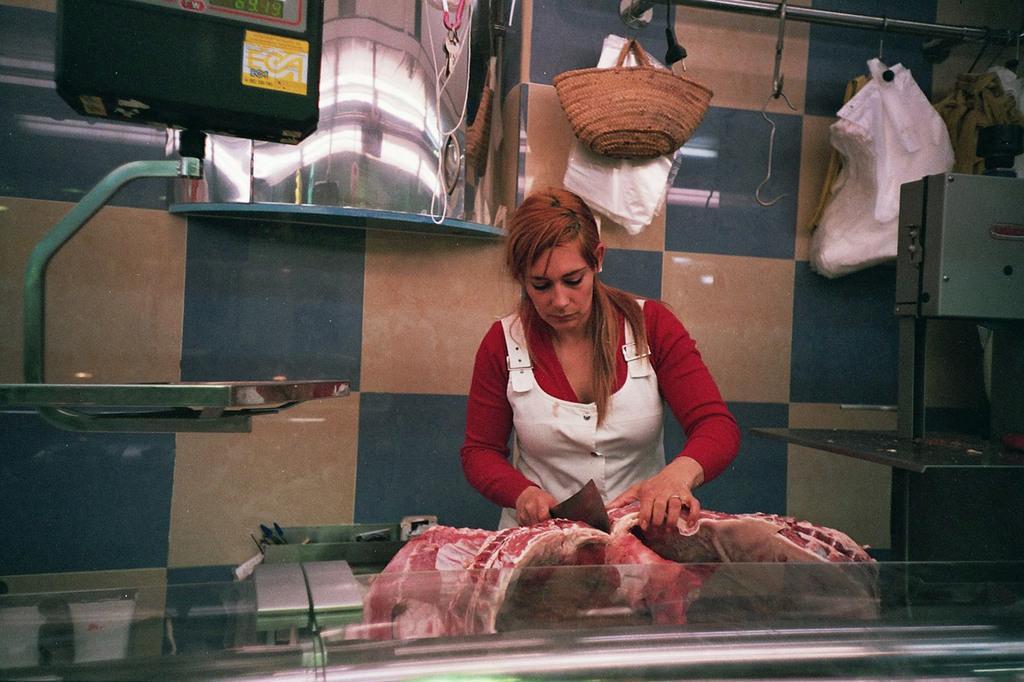Describe this image in one or two sentences. In the center of the image there is a woman cutting the meat. In the background there is a bag, covers, hangers, mirror and wall. 